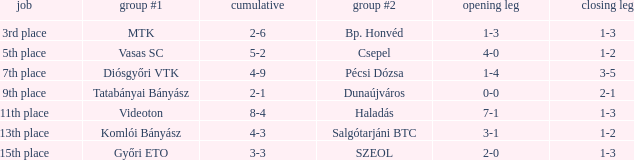What is the 1st leg of bp. honvéd team #2? 1-3. 